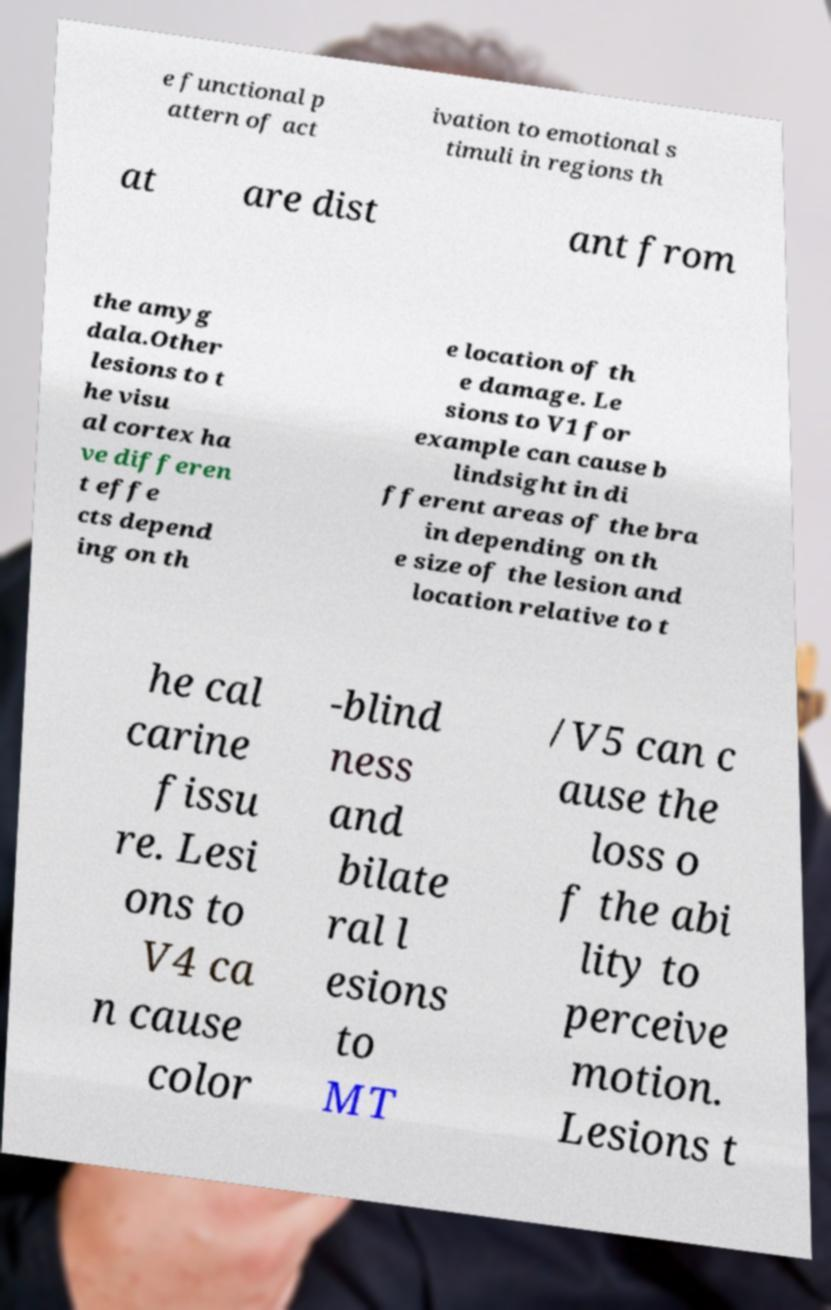I need the written content from this picture converted into text. Can you do that? e functional p attern of act ivation to emotional s timuli in regions th at are dist ant from the amyg dala.Other lesions to t he visu al cortex ha ve differen t effe cts depend ing on th e location of th e damage. Le sions to V1 for example can cause b lindsight in di fferent areas of the bra in depending on th e size of the lesion and location relative to t he cal carine fissu re. Lesi ons to V4 ca n cause color -blind ness and bilate ral l esions to MT /V5 can c ause the loss o f the abi lity to perceive motion. Lesions t 